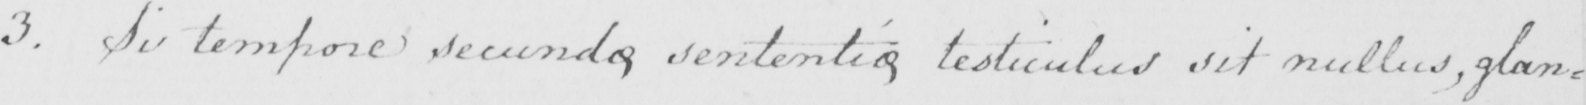Transcribe the text shown in this historical manuscript line. 3 . Si tempore secundo sententio testiculus sit nullus , glan= 